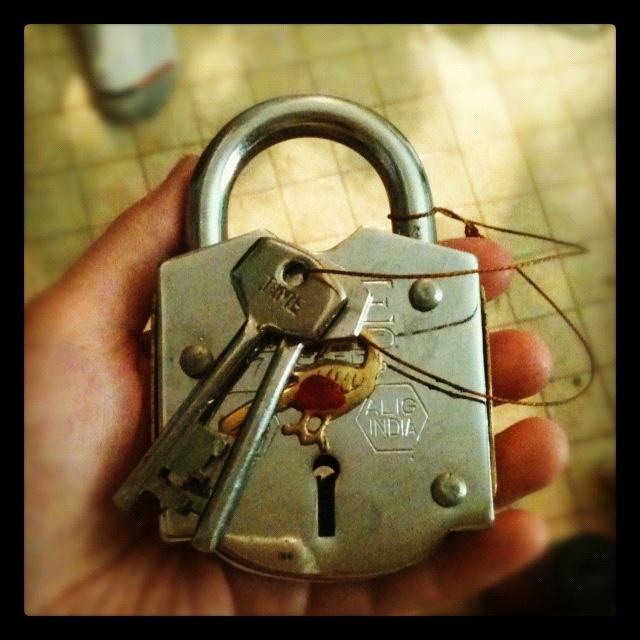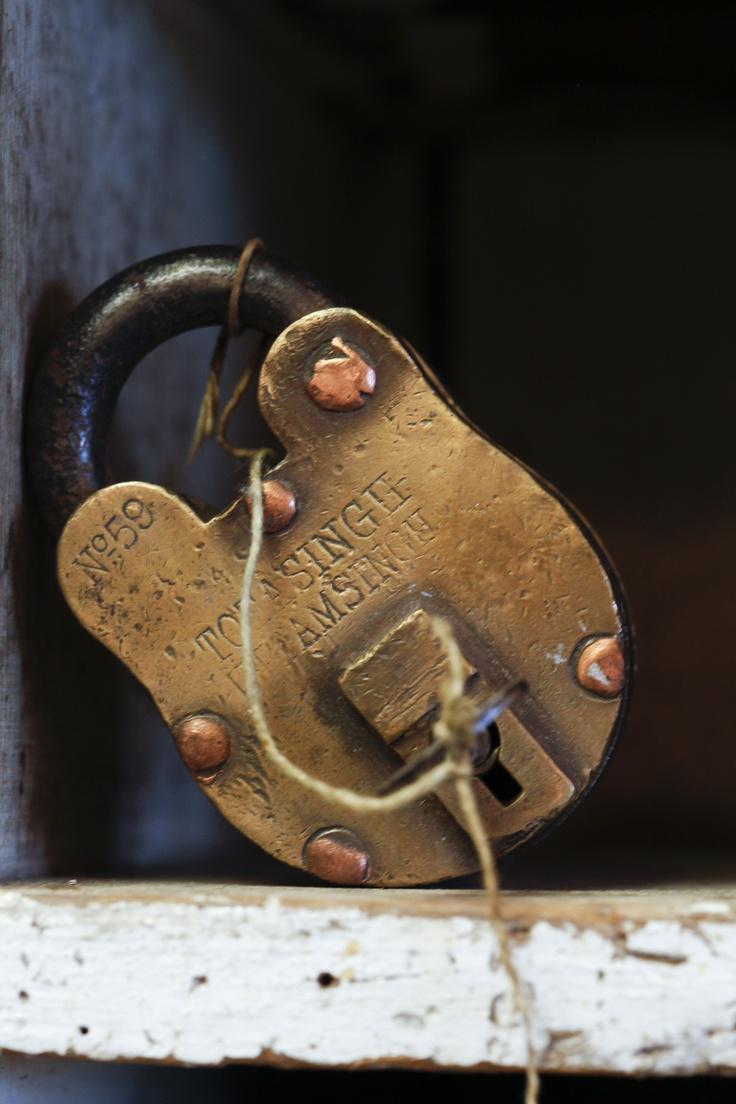The first image is the image on the left, the second image is the image on the right. For the images shown, is this caption "A lock is hanging on a chain in the image on the left." true? Answer yes or no. No. The first image is the image on the left, the second image is the image on the right. Assess this claim about the two images: "An image shows a rusty brownish chain attached to at least one lock, in front of brownish bars.". Correct or not? Answer yes or no. No. 